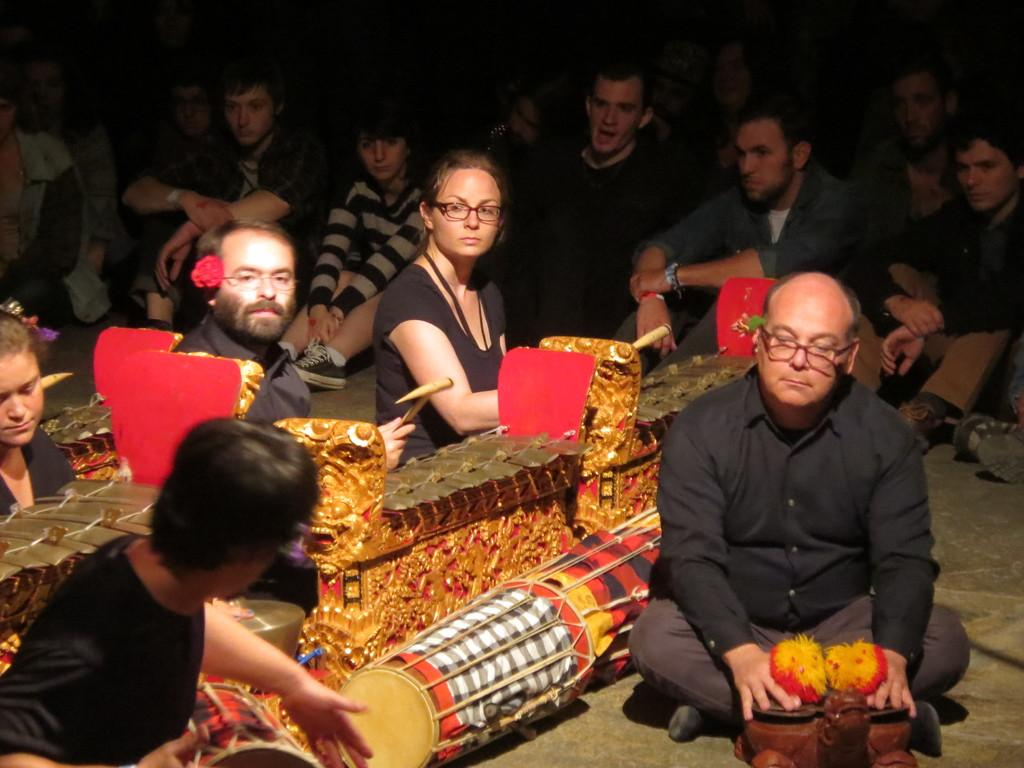What are the people in the image doing? The people in the image are sitting on the floor. What can be seen at the center of the image? There are musical instruments at the center of the image. What type of icicle can be seen hanging from the musical instruments in the image? There is no icicle present in the image; it is indoors and not cold enough for icicles to form. 